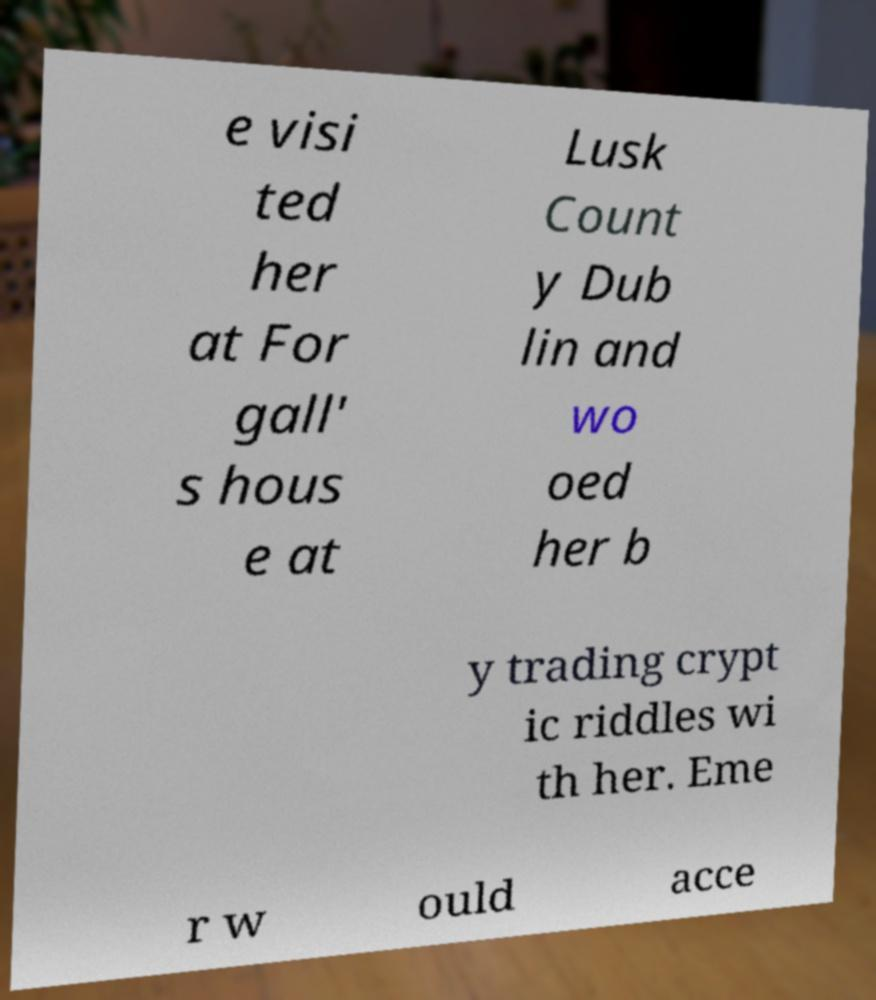Could you assist in decoding the text presented in this image and type it out clearly? e visi ted her at For gall' s hous e at Lusk Count y Dub lin and wo oed her b y trading crypt ic riddles wi th her. Eme r w ould acce 